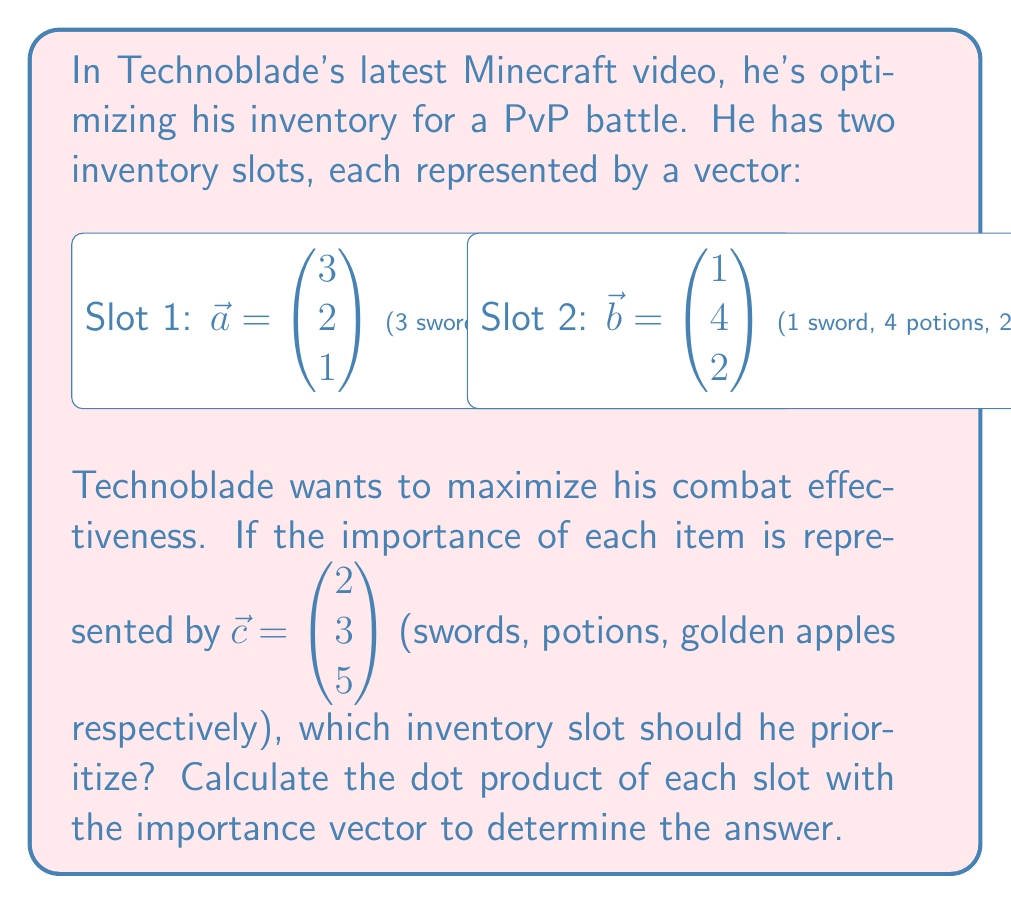Give your solution to this math problem. To solve this problem, we need to calculate the dot product of each inventory slot vector with the importance vector. The slot with the higher dot product value will be the one Technoblade should prioritize.

Step 1: Calculate the dot product of Slot 1 ($\vec{a}$) with the importance vector ($\vec{c}$):
$$\vec{a} \cdot \vec{c} = (3 \times 2) + (2 \times 3) + (1 \times 5) = 6 + 6 + 5 = 17$$

Step 2: Calculate the dot product of Slot 2 ($\vec{b}$) with the importance vector ($\vec{c}$):
$$\vec{b} \cdot \vec{c} = (1 \times 2) + (4 \times 3) + (2 \times 5) = 2 + 12 + 10 = 24$$

Step 3: Compare the results:
Slot 1: 17
Slot 2: 24

Since 24 > 17, Slot 2 has a higher combat effectiveness according to the importance vector.
Answer: Slot 2 (24 > 17) 